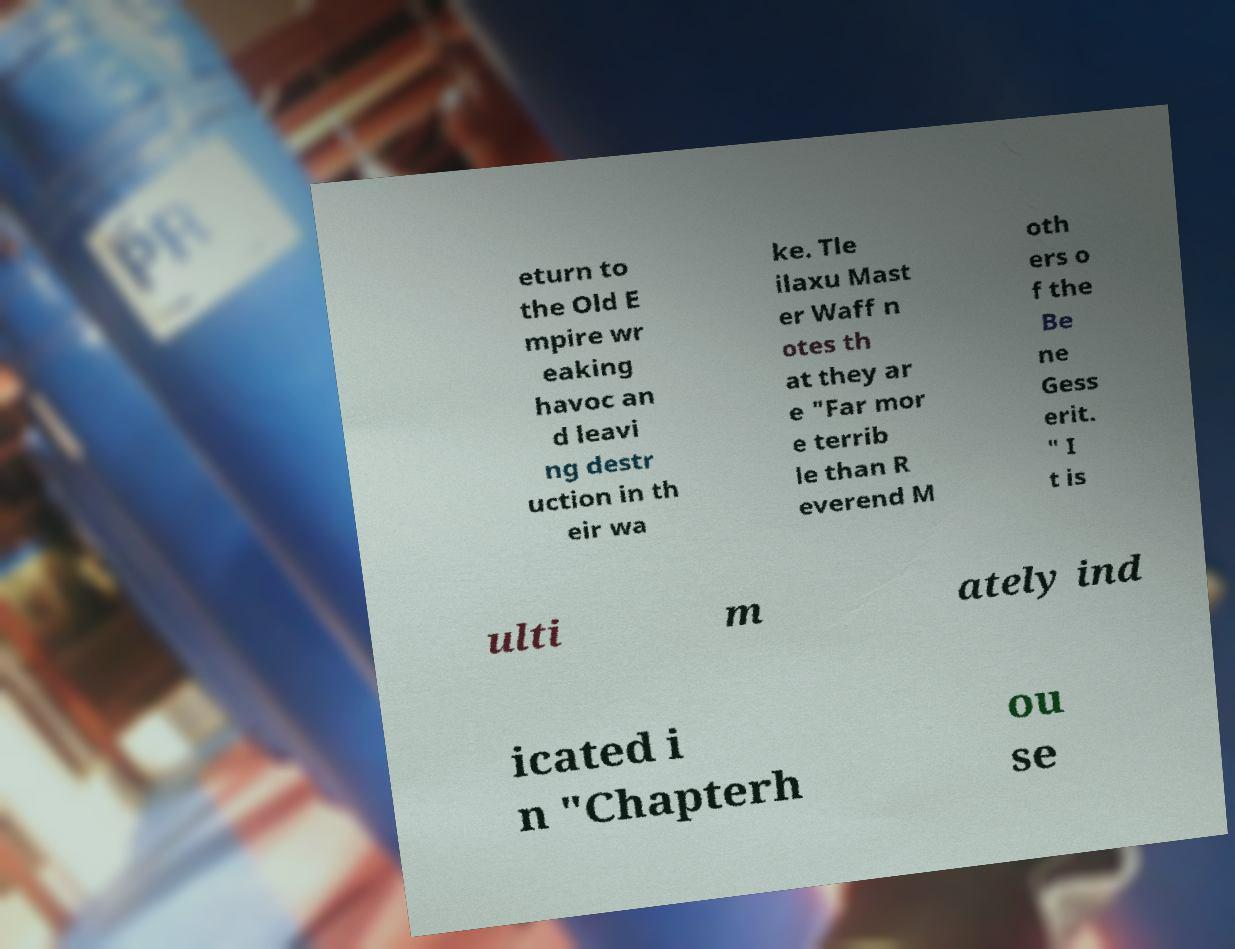Please read and relay the text visible in this image. What does it say? eturn to the Old E mpire wr eaking havoc an d leavi ng destr uction in th eir wa ke. Tle ilaxu Mast er Waff n otes th at they ar e "Far mor e terrib le than R everend M oth ers o f the Be ne Gess erit. " I t is ulti m ately ind icated i n "Chapterh ou se 